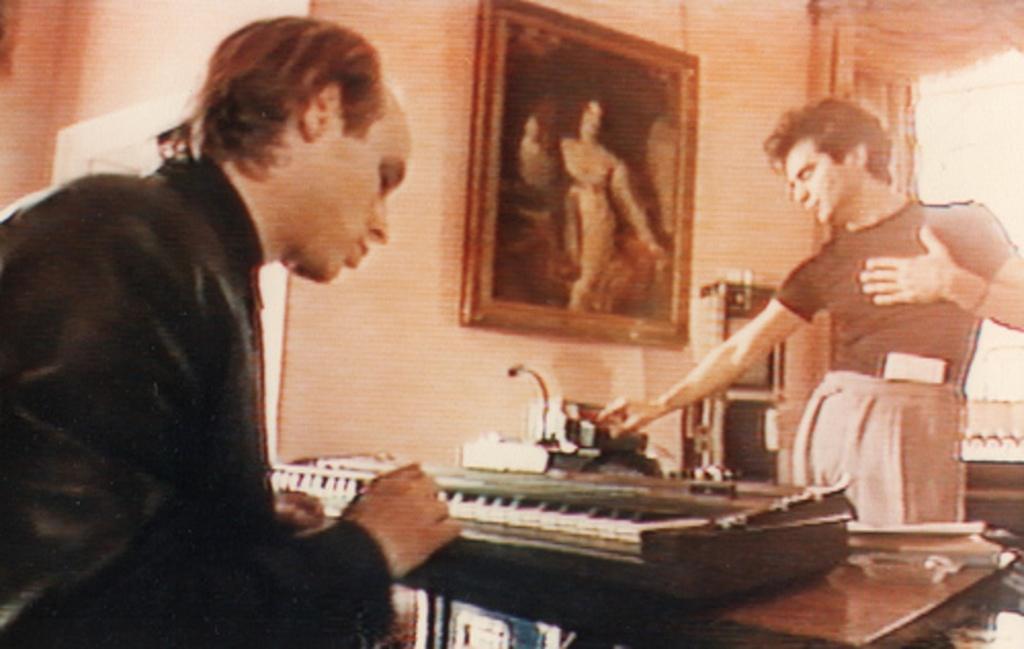Can you describe this image briefly? The person in the left corner is sitting in front of a piano and there is another person standing in front of him. 